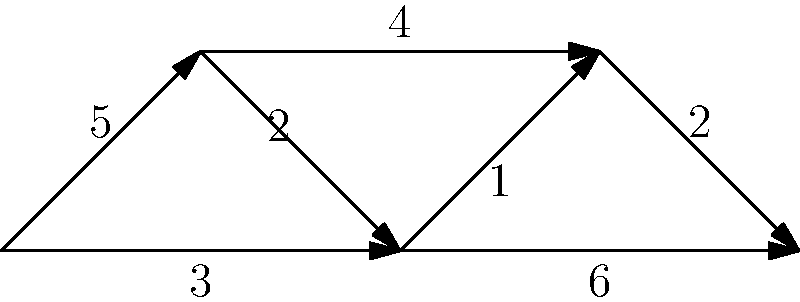Hey Jerry, remember how you always impressed me with your problem-solving skills? I've got a challenging network optimization problem for you. In the diagram above, we have a network with nodes A, B, C, D, and E, connected by directed edges with associated weights. What's the shortest path from node A to node E, and what's its total weight? To solve this problem, we'll use Dijkstra's algorithm, which you've always been great at implementing. Let's go through it step-by-step:

1) Initialize:
   - Set distance to A as 0, and all others as infinity.
   - Set all nodes as unvisited.
   - Set A as the current node.

2) For the current node, consider all unvisited neighbors and calculate their tentative distances:
   - From A: B (5), C (3)
   
3) Mark A as visited. B has tentative distance 5, C has 3. C is closer, so it becomes the current node.

4) From C, consider unvisited neighbors:
   - To B: 3 (to C) + 2 = 5 (no change)
   - To D: 3 (to C) + 1 = 4
   - To E: 3 (to C) + 6 = 9

5) Mark C as visited. D is now closest unvisited node (4), so it becomes current.

6) From D, consider unvisited neighbors:
   - To E: 4 (to D) + 2 = 6

7) Mark D as visited. B is now closest unvisited node (5), but all its neighbors are visited.

8) Mark B as visited. E is the only unvisited node left, with a distance of 6.

The shortest path is A → C → D → E, with a total weight of 6.
Answer: A → C → D → E, weight 6 